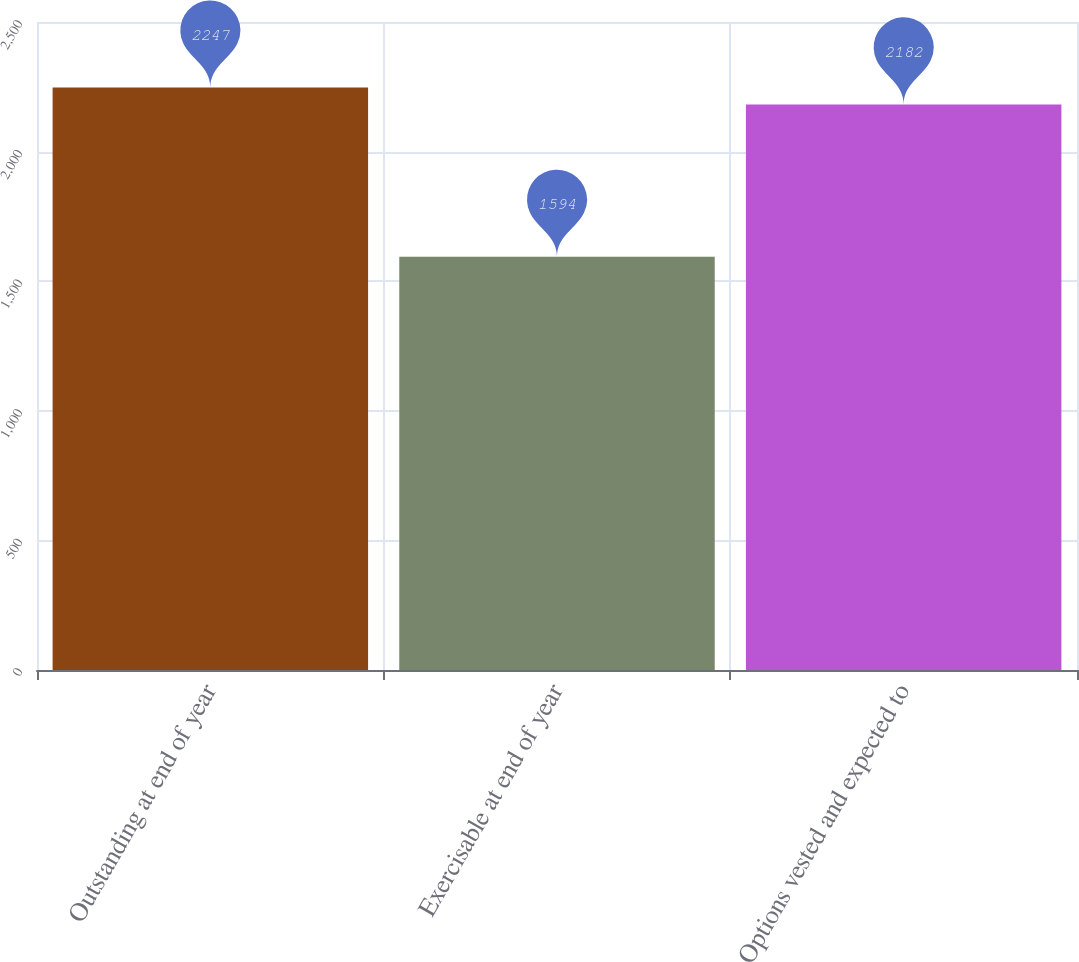<chart> <loc_0><loc_0><loc_500><loc_500><bar_chart><fcel>Outstanding at end of year<fcel>Exercisable at end of year<fcel>Options vested and expected to<nl><fcel>2247<fcel>1594<fcel>2182<nl></chart> 